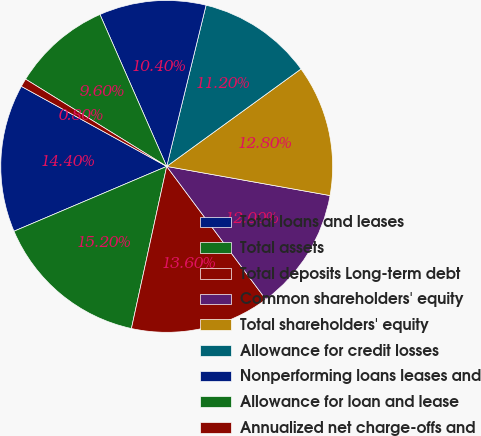Convert chart. <chart><loc_0><loc_0><loc_500><loc_500><pie_chart><fcel>Total loans and leases<fcel>Total assets<fcel>Total deposits Long-term debt<fcel>Common shareholders' equity<fcel>Total shareholders' equity<fcel>Allowance for credit losses<fcel>Nonperforming loans leases and<fcel>Allowance for loan and lease<fcel>Annualized net charge-offs and<nl><fcel>14.4%<fcel>15.2%<fcel>13.6%<fcel>12.0%<fcel>12.8%<fcel>11.2%<fcel>10.4%<fcel>9.6%<fcel>0.8%<nl></chart> 